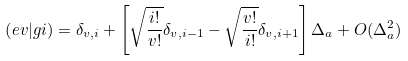Convert formula to latex. <formula><loc_0><loc_0><loc_500><loc_500>\left ( e v | g i \right ) = \delta _ { v , i } + \left [ \sqrt { \frac { i ! } { v ! } } \delta _ { v , i - 1 } - \sqrt { \frac { v ! } { i ! } } \delta _ { v , i + 1 } \right ] \Delta _ { a } + O ( \Delta _ { a } ^ { 2 } )</formula> 